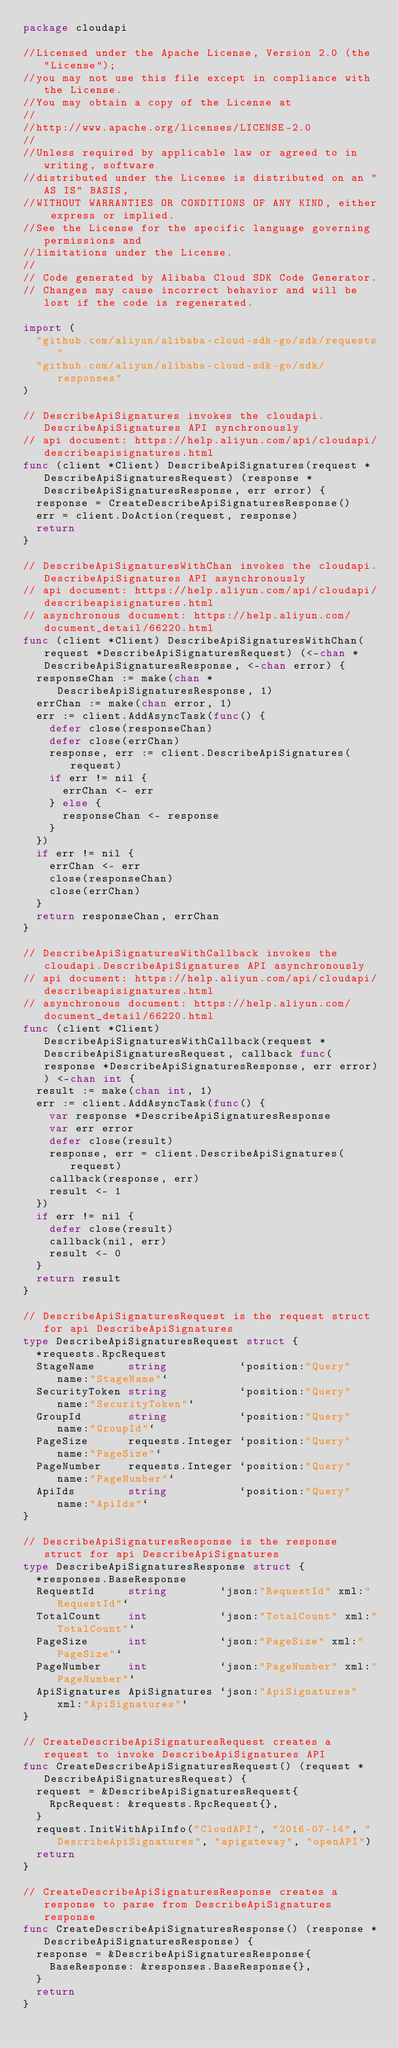<code> <loc_0><loc_0><loc_500><loc_500><_Go_>package cloudapi

//Licensed under the Apache License, Version 2.0 (the "License");
//you may not use this file except in compliance with the License.
//You may obtain a copy of the License at
//
//http://www.apache.org/licenses/LICENSE-2.0
//
//Unless required by applicable law or agreed to in writing, software
//distributed under the License is distributed on an "AS IS" BASIS,
//WITHOUT WARRANTIES OR CONDITIONS OF ANY KIND, either express or implied.
//See the License for the specific language governing permissions and
//limitations under the License.
//
// Code generated by Alibaba Cloud SDK Code Generator.
// Changes may cause incorrect behavior and will be lost if the code is regenerated.

import (
	"github.com/aliyun/alibaba-cloud-sdk-go/sdk/requests"
	"github.com/aliyun/alibaba-cloud-sdk-go/sdk/responses"
)

// DescribeApiSignatures invokes the cloudapi.DescribeApiSignatures API synchronously
// api document: https://help.aliyun.com/api/cloudapi/describeapisignatures.html
func (client *Client) DescribeApiSignatures(request *DescribeApiSignaturesRequest) (response *DescribeApiSignaturesResponse, err error) {
	response = CreateDescribeApiSignaturesResponse()
	err = client.DoAction(request, response)
	return
}

// DescribeApiSignaturesWithChan invokes the cloudapi.DescribeApiSignatures API asynchronously
// api document: https://help.aliyun.com/api/cloudapi/describeapisignatures.html
// asynchronous document: https://help.aliyun.com/document_detail/66220.html
func (client *Client) DescribeApiSignaturesWithChan(request *DescribeApiSignaturesRequest) (<-chan *DescribeApiSignaturesResponse, <-chan error) {
	responseChan := make(chan *DescribeApiSignaturesResponse, 1)
	errChan := make(chan error, 1)
	err := client.AddAsyncTask(func() {
		defer close(responseChan)
		defer close(errChan)
		response, err := client.DescribeApiSignatures(request)
		if err != nil {
			errChan <- err
		} else {
			responseChan <- response
		}
	})
	if err != nil {
		errChan <- err
		close(responseChan)
		close(errChan)
	}
	return responseChan, errChan
}

// DescribeApiSignaturesWithCallback invokes the cloudapi.DescribeApiSignatures API asynchronously
// api document: https://help.aliyun.com/api/cloudapi/describeapisignatures.html
// asynchronous document: https://help.aliyun.com/document_detail/66220.html
func (client *Client) DescribeApiSignaturesWithCallback(request *DescribeApiSignaturesRequest, callback func(response *DescribeApiSignaturesResponse, err error)) <-chan int {
	result := make(chan int, 1)
	err := client.AddAsyncTask(func() {
		var response *DescribeApiSignaturesResponse
		var err error
		defer close(result)
		response, err = client.DescribeApiSignatures(request)
		callback(response, err)
		result <- 1
	})
	if err != nil {
		defer close(result)
		callback(nil, err)
		result <- 0
	}
	return result
}

// DescribeApiSignaturesRequest is the request struct for api DescribeApiSignatures
type DescribeApiSignaturesRequest struct {
	*requests.RpcRequest
	StageName     string           `position:"Query" name:"StageName"`
	SecurityToken string           `position:"Query" name:"SecurityToken"`
	GroupId       string           `position:"Query" name:"GroupId"`
	PageSize      requests.Integer `position:"Query" name:"PageSize"`
	PageNumber    requests.Integer `position:"Query" name:"PageNumber"`
	ApiIds        string           `position:"Query" name:"ApiIds"`
}

// DescribeApiSignaturesResponse is the response struct for api DescribeApiSignatures
type DescribeApiSignaturesResponse struct {
	*responses.BaseResponse
	RequestId     string        `json:"RequestId" xml:"RequestId"`
	TotalCount    int           `json:"TotalCount" xml:"TotalCount"`
	PageSize      int           `json:"PageSize" xml:"PageSize"`
	PageNumber    int           `json:"PageNumber" xml:"PageNumber"`
	ApiSignatures ApiSignatures `json:"ApiSignatures" xml:"ApiSignatures"`
}

// CreateDescribeApiSignaturesRequest creates a request to invoke DescribeApiSignatures API
func CreateDescribeApiSignaturesRequest() (request *DescribeApiSignaturesRequest) {
	request = &DescribeApiSignaturesRequest{
		RpcRequest: &requests.RpcRequest{},
	}
	request.InitWithApiInfo("CloudAPI", "2016-07-14", "DescribeApiSignatures", "apigateway", "openAPI")
	return
}

// CreateDescribeApiSignaturesResponse creates a response to parse from DescribeApiSignatures response
func CreateDescribeApiSignaturesResponse() (response *DescribeApiSignaturesResponse) {
	response = &DescribeApiSignaturesResponse{
		BaseResponse: &responses.BaseResponse{},
	}
	return
}
</code> 